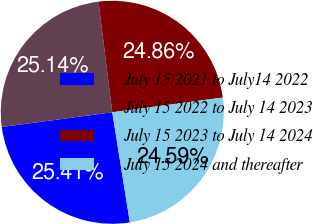Convert chart to OTSL. <chart><loc_0><loc_0><loc_500><loc_500><pie_chart><fcel>July 15 2021 to July14 2022<fcel>July 15 2022 to July 14 2023<fcel>July 15 2023 to July 14 2024<fcel>July 15 2024 and thereafter<nl><fcel>25.41%<fcel>25.14%<fcel>24.86%<fcel>24.59%<nl></chart> 